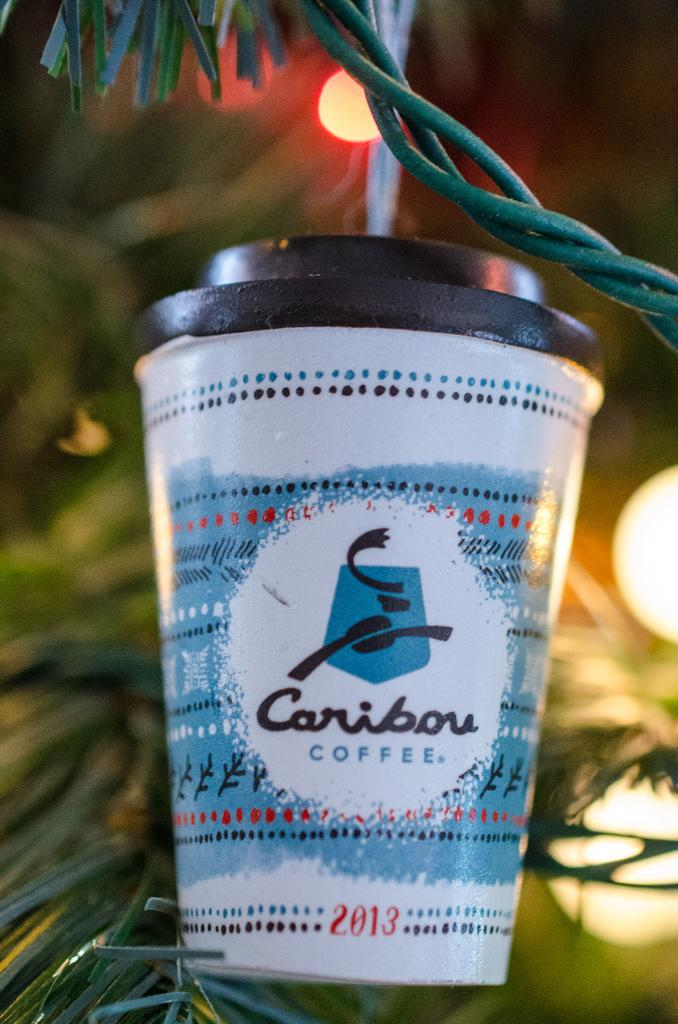<image>
Render a clear and concise summary of the photo. A Caribou coffee cup ornament placed on a Christmas tree. 